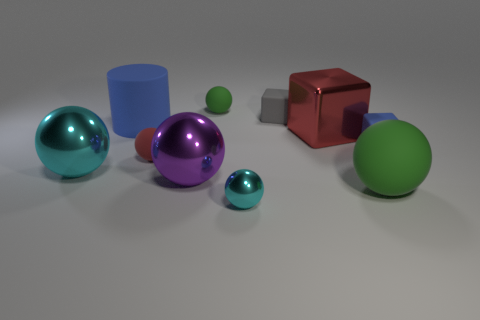Subtract all cyan spheres. How many spheres are left? 4 Subtract all red balls. How many balls are left? 5 Subtract all purple balls. Subtract all green cylinders. How many balls are left? 5 Subtract all cylinders. How many objects are left? 9 Add 9 tiny blue things. How many tiny blue things are left? 10 Add 5 big green rubber things. How many big green rubber things exist? 6 Subtract 1 purple spheres. How many objects are left? 9 Subtract all tiny red balls. Subtract all small blue cubes. How many objects are left? 8 